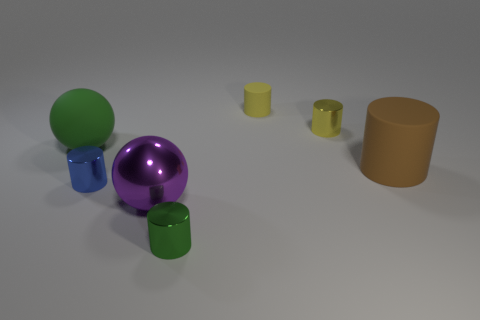Subtract 2 cylinders. How many cylinders are left? 3 Subtract all yellow rubber cylinders. How many cylinders are left? 4 Subtract all blue cylinders. How many cylinders are left? 4 Subtract all cyan cylinders. Subtract all gray cubes. How many cylinders are left? 5 Add 2 large green rubber spheres. How many objects exist? 9 Subtract all cylinders. How many objects are left? 2 Subtract 0 gray cylinders. How many objects are left? 7 Subtract all big green matte cylinders. Subtract all spheres. How many objects are left? 5 Add 4 large purple metal balls. How many large purple metal balls are left? 5 Add 2 large shiny cylinders. How many large shiny cylinders exist? 2 